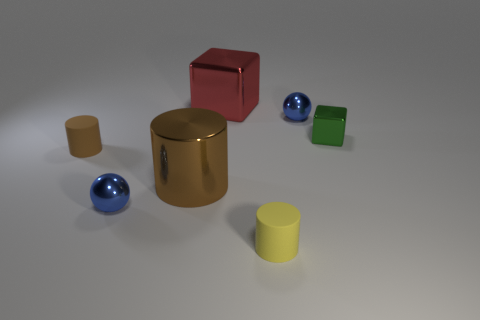Add 1 large gray cylinders. How many objects exist? 8 Subtract all spheres. How many objects are left? 5 Add 1 small brown cylinders. How many small brown cylinders are left? 2 Add 6 cubes. How many cubes exist? 8 Subtract 0 purple balls. How many objects are left? 7 Subtract all big blue matte spheres. Subtract all brown rubber cylinders. How many objects are left? 6 